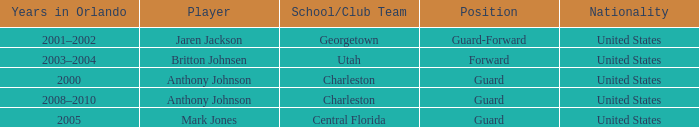What position did the player britton johnsen hold? Forward. 